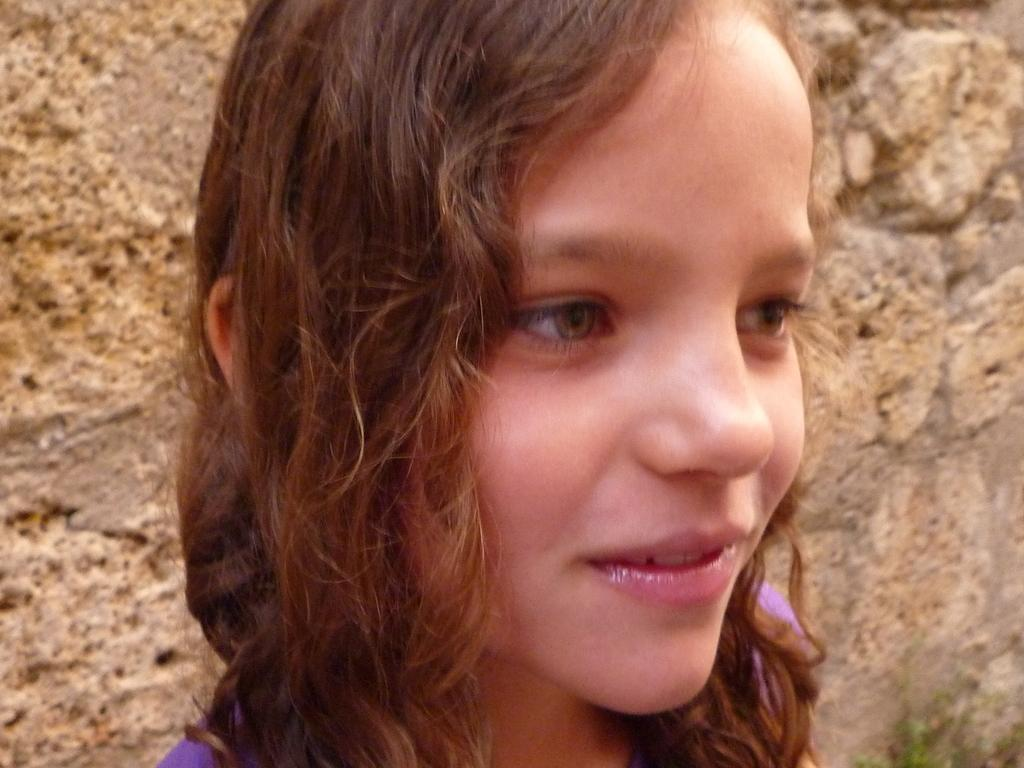Who is present in the image? There is a girl in the image. What can be seen in the background of the image? There is a wall in the background of the image. What type of animal is sitting on the girl's shoulder in the image? There is no animal present on the girl's shoulder in the image. How many cherries can be seen on the girl's head in the image? There are no cherries present on the girl's head in the image. 